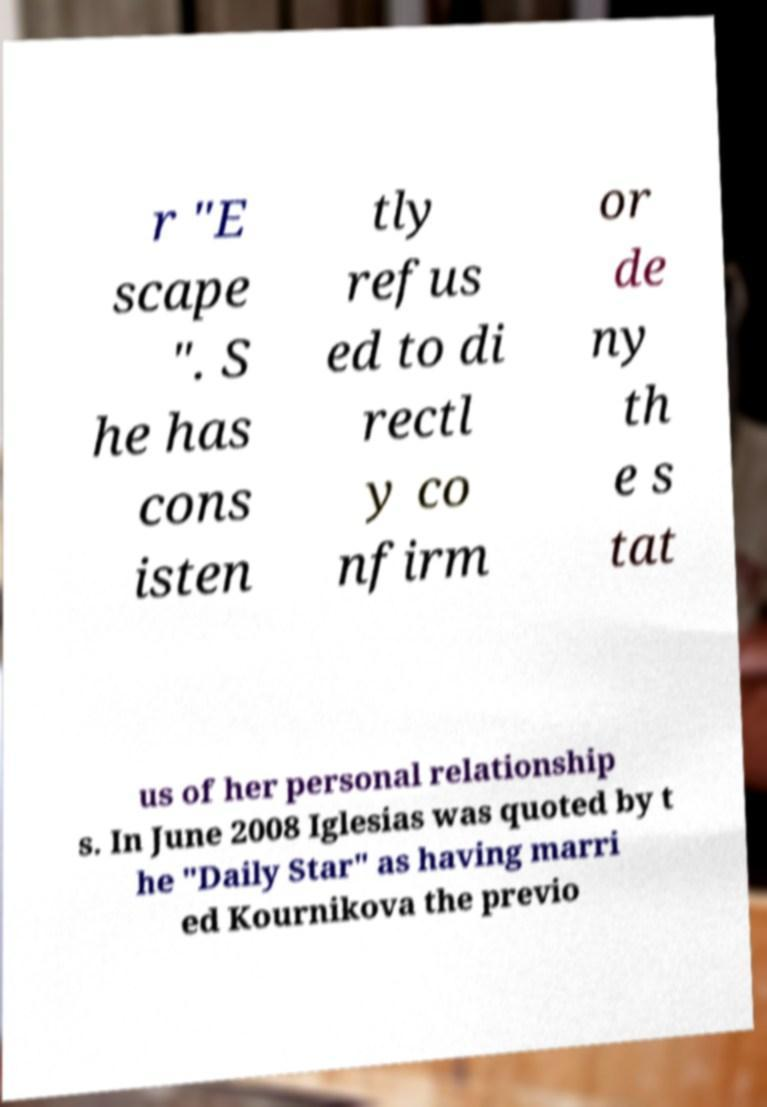Please identify and transcribe the text found in this image. r "E scape ". S he has cons isten tly refus ed to di rectl y co nfirm or de ny th e s tat us of her personal relationship s. In June 2008 Iglesias was quoted by t he "Daily Star" as having marri ed Kournikova the previo 